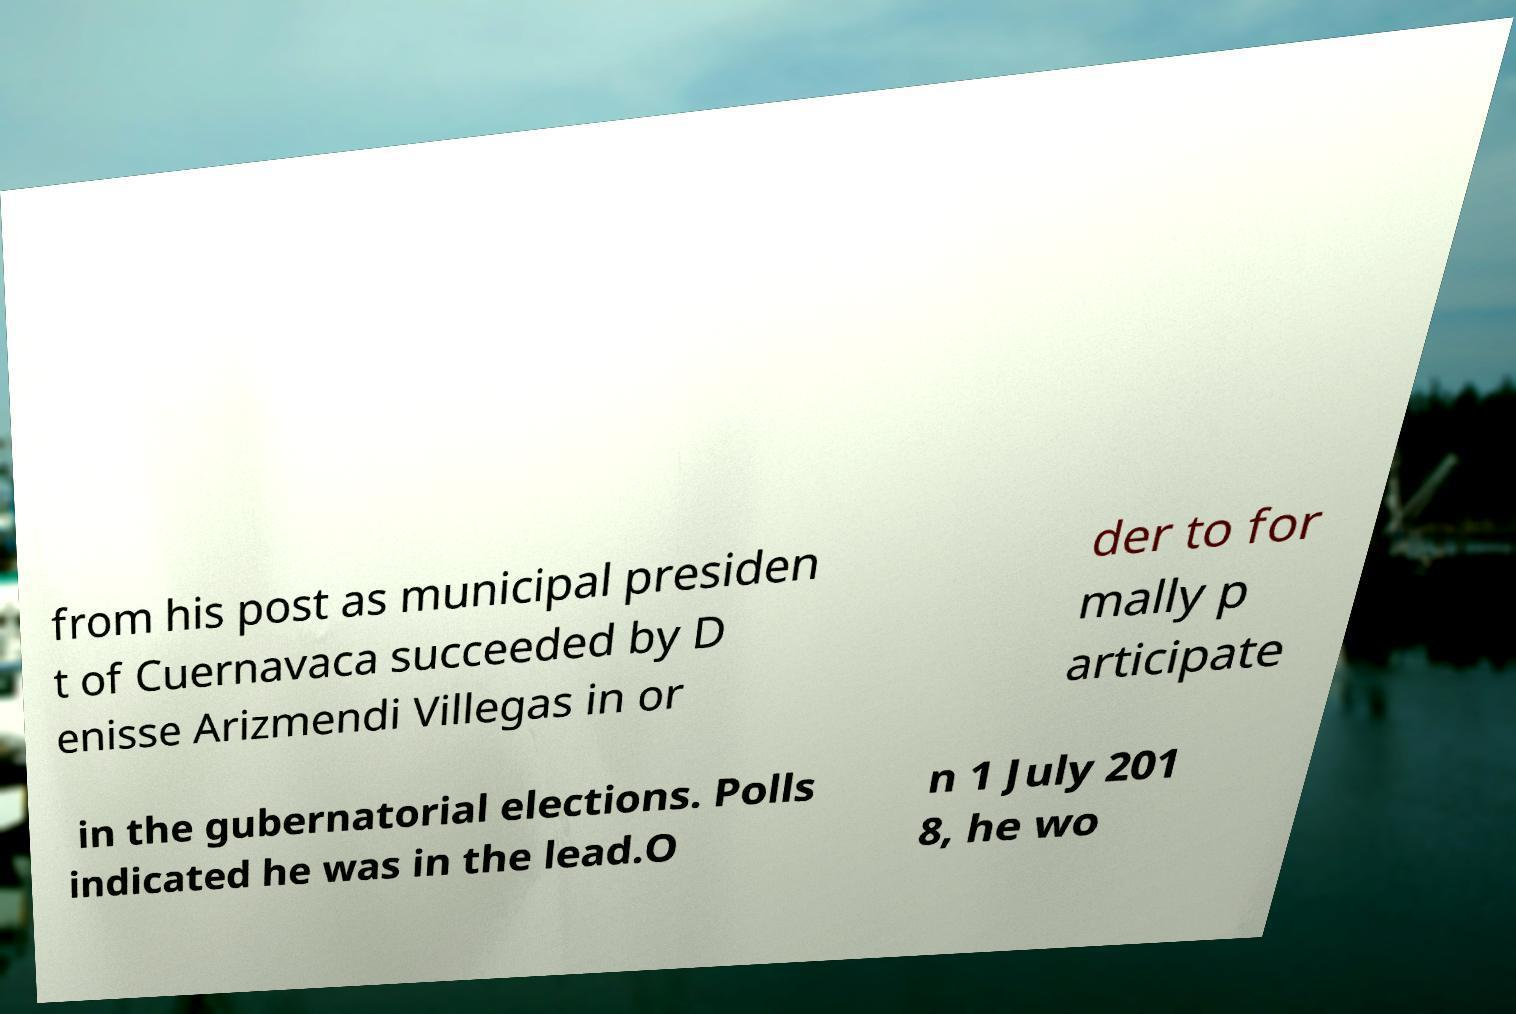I need the written content from this picture converted into text. Can you do that? from his post as municipal presiden t of Cuernavaca succeeded by D enisse Arizmendi Villegas in or der to for mally p articipate in the gubernatorial elections. Polls indicated he was in the lead.O n 1 July 201 8, he wo 